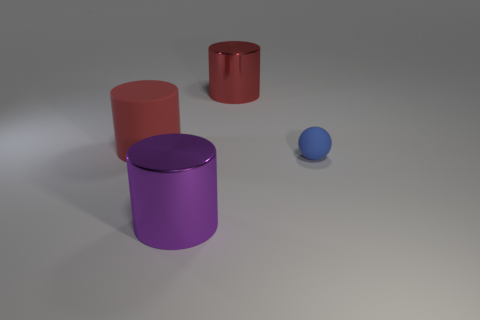Add 4 big purple metallic objects. How many objects exist? 8 Subtract all spheres. How many objects are left? 3 Subtract all big rubber cylinders. Subtract all big brown objects. How many objects are left? 3 Add 1 big red shiny cylinders. How many big red shiny cylinders are left? 2 Add 3 purple rubber cylinders. How many purple rubber cylinders exist? 3 Subtract 0 gray blocks. How many objects are left? 4 